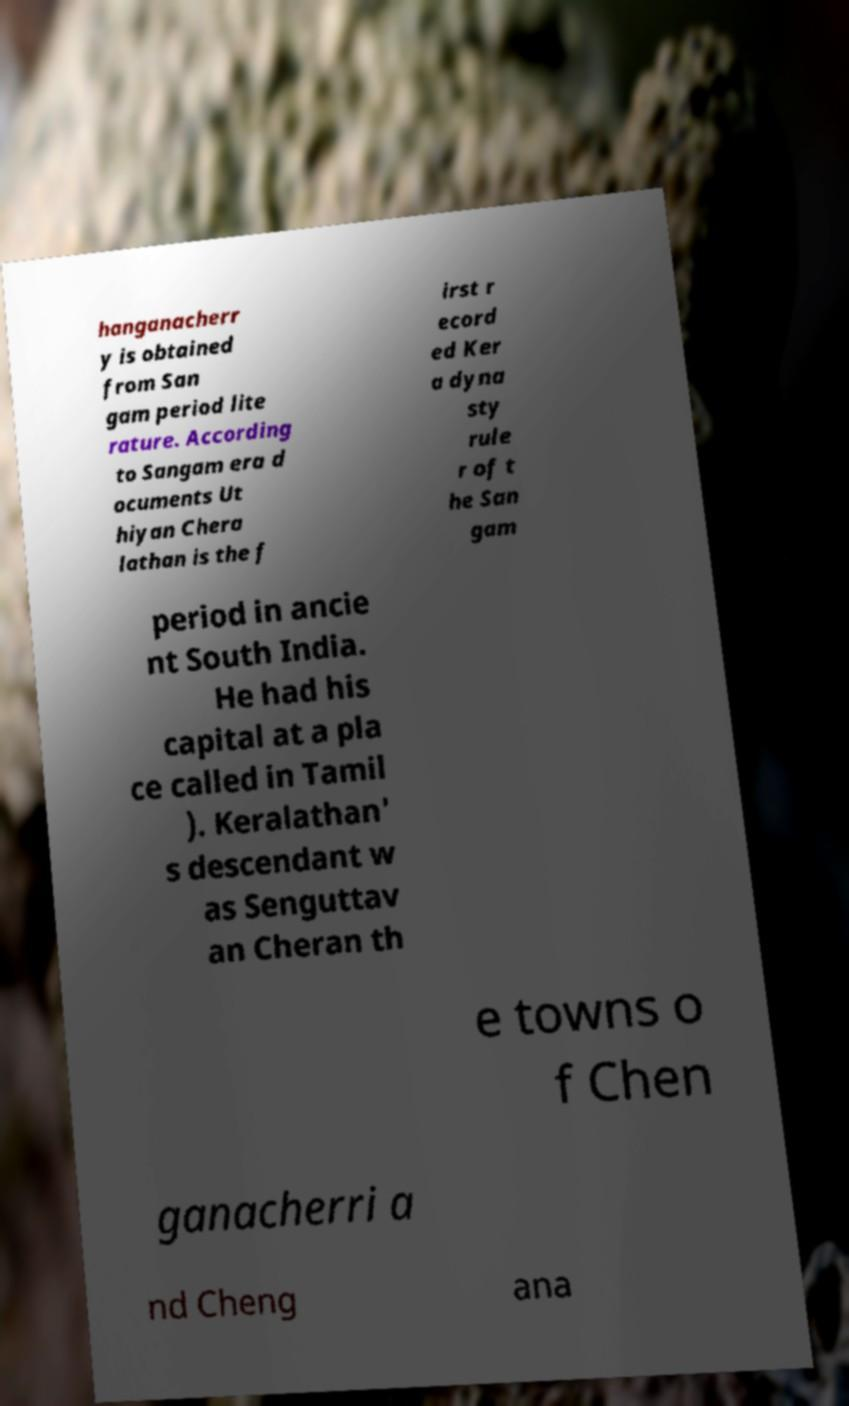What messages or text are displayed in this image? I need them in a readable, typed format. hanganacherr y is obtained from San gam period lite rature. According to Sangam era d ocuments Ut hiyan Chera lathan is the f irst r ecord ed Ker a dyna sty rule r of t he San gam period in ancie nt South India. He had his capital at a pla ce called in Tamil ). Keralathan' s descendant w as Senguttav an Cheran th e towns o f Chen ganacherri a nd Cheng ana 